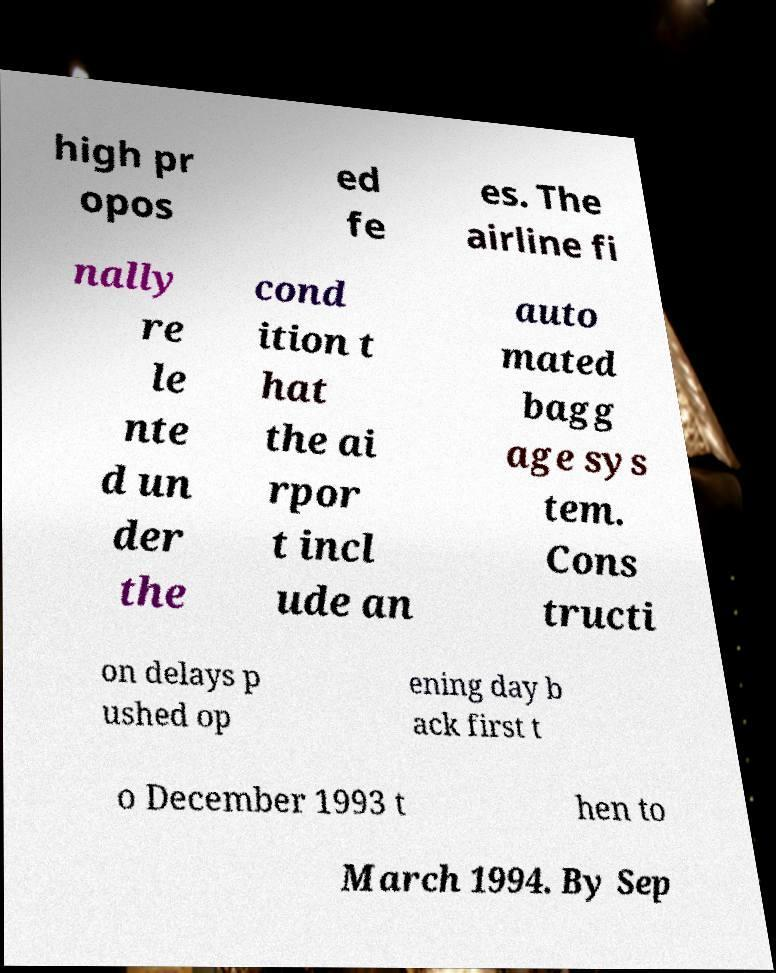For documentation purposes, I need the text within this image transcribed. Could you provide that? high pr opos ed fe es. The airline fi nally re le nte d un der the cond ition t hat the ai rpor t incl ude an auto mated bagg age sys tem. Cons tructi on delays p ushed op ening day b ack first t o December 1993 t hen to March 1994. By Sep 